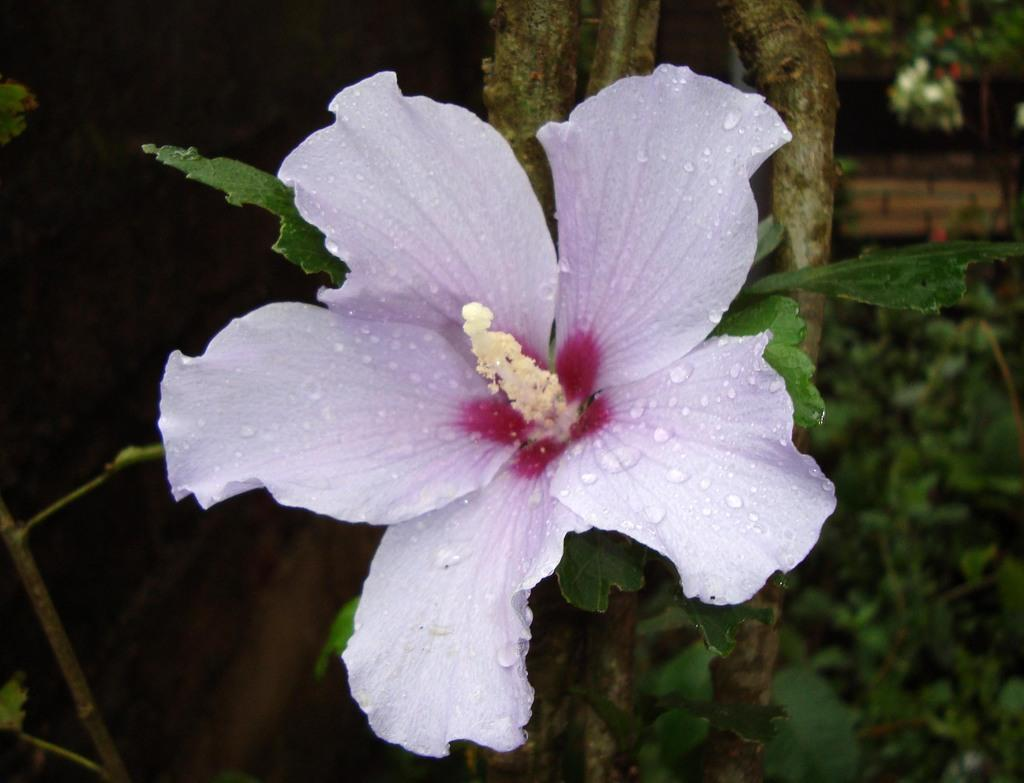What type of flower is in the image? There is a hibiscus flower in the image. Can you describe the background of the image? The background of the image appears blurry and green. Where is the receipt located in the image? There is no receipt present in the image. What type of creature is sitting on top of the hibiscus flower in the image? There is no creature present on top of the hibiscus flower in the image. 